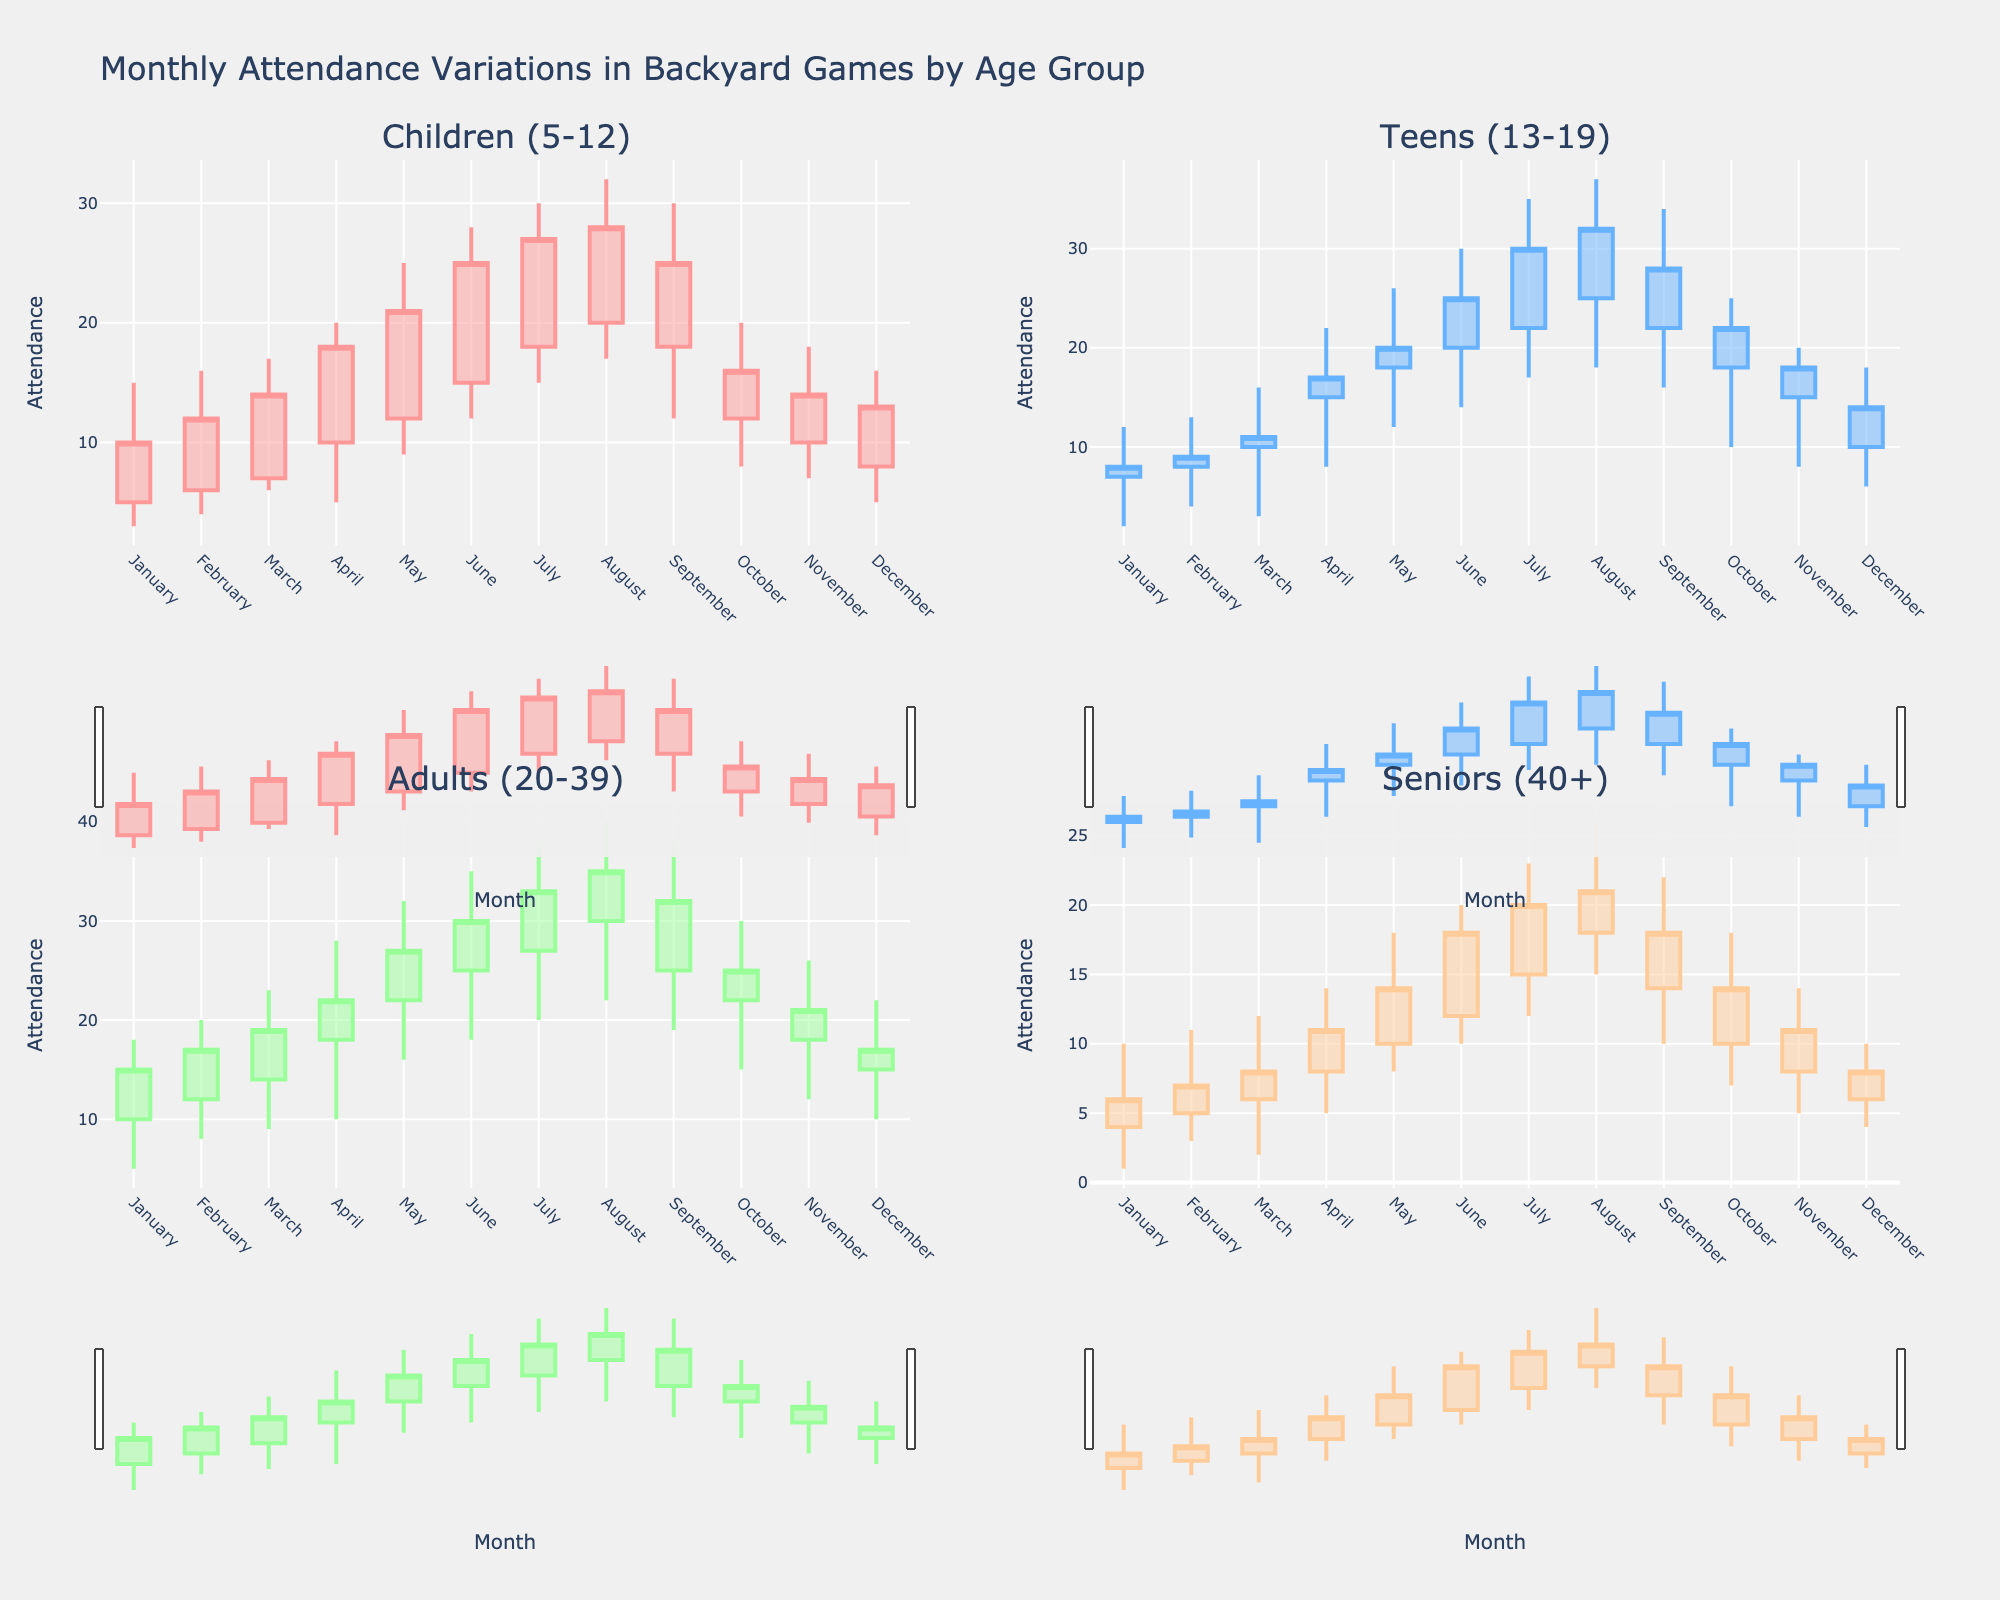What is the title of the figure? The title of the figure is generally located at the top of the plot and it summarizes the content of the chart. In this case, it clearly states: "Monthly Attendance Variations in Backyard Games by Age Group"
Answer: Monthly Attendance Variations in Backyard Games by Age Group How many subplots are there in the figure, and what do they represent? There are four subplots in the figure, arranged in a 2x2 grid. Each subplot represents one of the age groups: Children (5-12), Teens (13-19), Adults (20-39), and Seniors (40+).
Answer: Four subplots, each representing a different age group Which age group had the highest attendance in August? By observing the candlestick plot for each age group in August, we see that the Adults (20-39) group had the highest attendance, with a high value of 40.
Answer: Adults (20-39) Which month had the highest attendance for the Children (5-12) age group? The highest attendance for the Children (5-12) age group is depicted in June, with a high value of 28.
Answer: June What was the approximate range of attendance for the Teens (13-19) group in May? For the Teens (13-19) group in May, the range is calculated from the high value to the low value. The high value is 26, and the low value is 12, so the range is 26 - 12 = 14.
Answer: 14 How does the attendance variability in March compare between the Children (5-12) and Teens (13-19) groups? For variability, compare the high and low values of the candlesticks: Children (5-12) group ranges from 17 to 6, and the Teens (13-19) group ranges from 16 to 3. Therefore, the Children group has less variability (11 units) compared to the Teens group (13 units).
Answer: The Teens (13-19) group has higher variability (13 units vs 11 units) What was the highest recorded attendance for the Seniors (40+) group, and in which month did it occur? By checking the high values in the candlestick plots for the Seniors (40+) group across all months, the highest recorded attendance is 26, which occurred in August.
Answer: 26, August What trend can be observed in the median attendance values for the Adults (20-39) group over the summer months (June to August)? Focus on the close values for June, July, and August in the Adults (20-39) candlestick plot: 30, 33, and 35 respectively. The median value over these months shows an increasing trend.
Answer: Increasing trend Calculate the average opening attendance for the Teens (13-19) group over three consecutive months, April, May, and June. Sum the open values for the Teens (13-19) group in April (15), May (18), and June (20), then divide by 3. (15 + 18 + 20) / 3 = 53 / 3 ≈ 17.67.
Answer: 17.67 